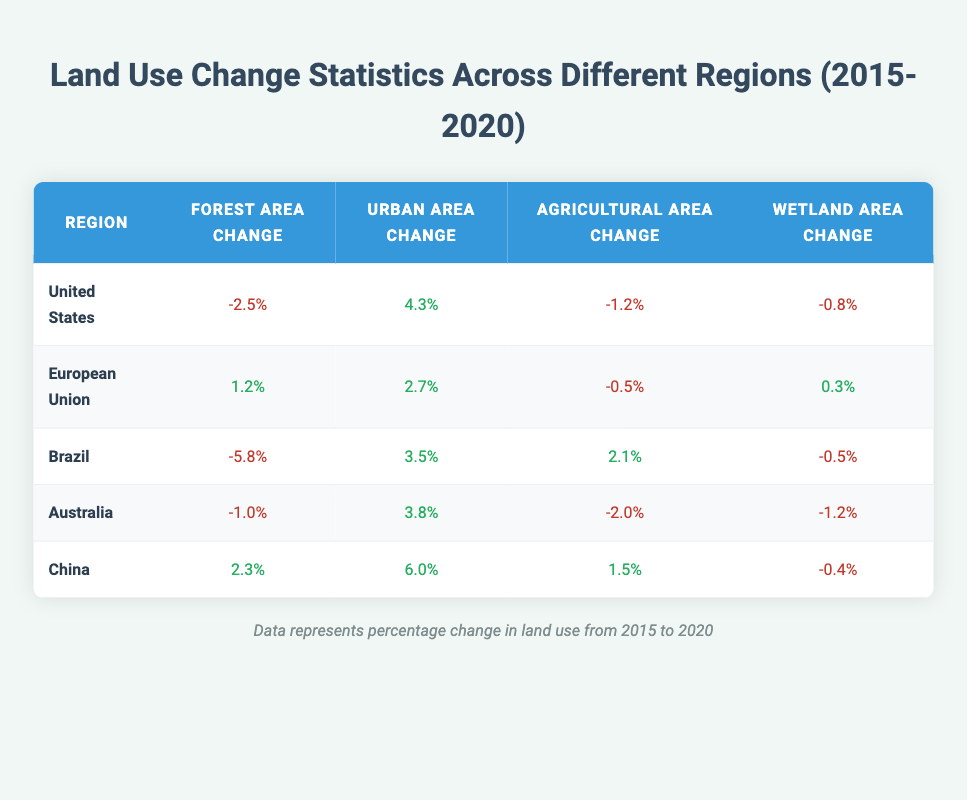What was the forest area change in the United States from 2015 to 2020? The table shows that the forest area change in the United States from 2015 to 2020 is -2.5%.
Answer: -2.5% Is the urban area change in Brazil positive or negative? The table indicates that the urban area change in Brazil from 2015 to 2020 is 3.5%, which is a positive change.
Answer: Positive Which region experienced the highest increase in urban area from 2015 to 2020? By examining the urban area changes for all regions, China shows the highest increase of 6.0%.
Answer: China What is the total change in forest area for the European Union and Australia combined from 2015 to 2020? The forest area change in the European Union is 1.2% and in Australia is -1.0%. Adding these gives a total of (1.2 + (-1.0)) = 0.2%.
Answer: 0.2% Did any region have both positive forest and wetland area changes from 2015 to 2020? Looking at the forest and wetland area changes, the European Union had a positive change in forest area (1.2%) and a positive change in wetland area (0.3%).
Answer: Yes What is the average agricultural area change for all regions from 2015 to 2020? The agricultural area changes are -1.2%, -0.5%, 2.1%, -2.0%, and 1.5%. The total is (-1.2 - 0.5 + 2.1 - 2.0 + 1.5) = 0.9%, and the average change is 0.9 / 5 = 0.18%.
Answer: 0.18% Which region had the most significant loss in forest area from 2015 to 2020? The table shows Brazil with the most significant loss in forest area at -5.8%.
Answer: Brazil Is there a region where both agricultural and wetland area changes were negative from 2015 to 2020? By checking the changes, Australia had both negative changes in agricultural area (-2.0%) and wetland area (-1.2%).
Answer: Yes 